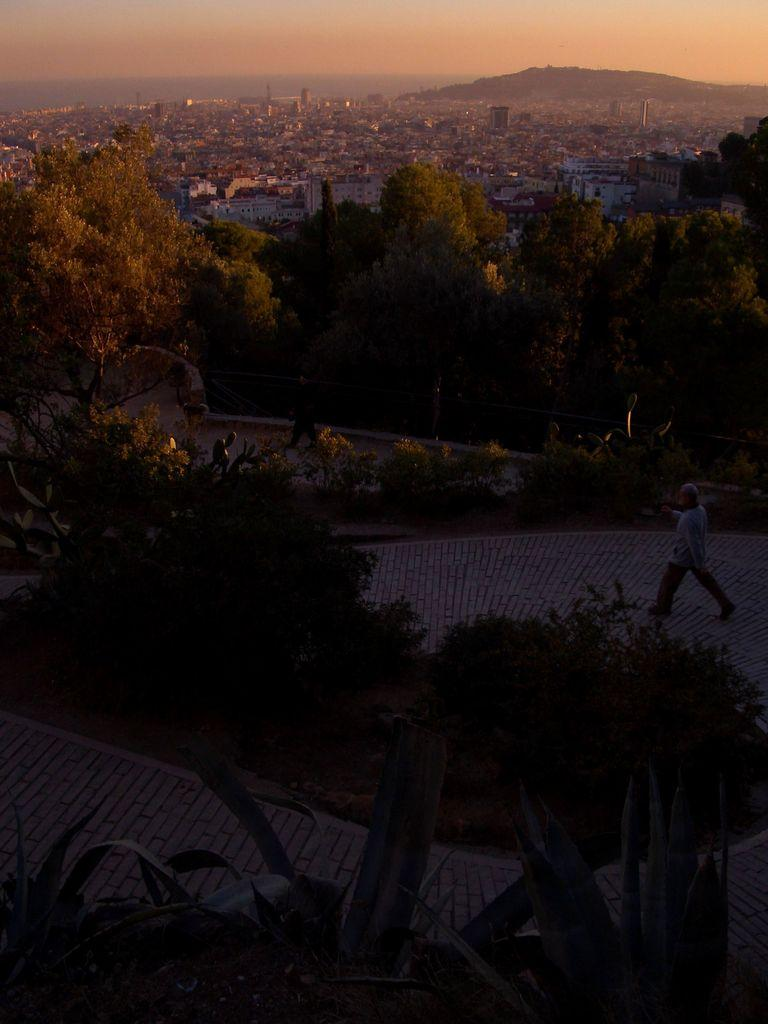What can be seen in the image that people walk on? There is a path in the image that people walk on. What type of natural elements are present around the path? Trees are present around the path. Can you describe the person walking on the path? There is a man walking on the path. What structures can be seen in the distance? Houses and buildings are visible in the background. What geographical feature is visible in the background? There is a mountain in the background. What type of industry can be seen near the ocean in the image? There is no industry or ocean present in the image. What is the man walking on the path holding in his tail? The man does not have a tail, as he is a human, and there are no animals mentioned in the image. 